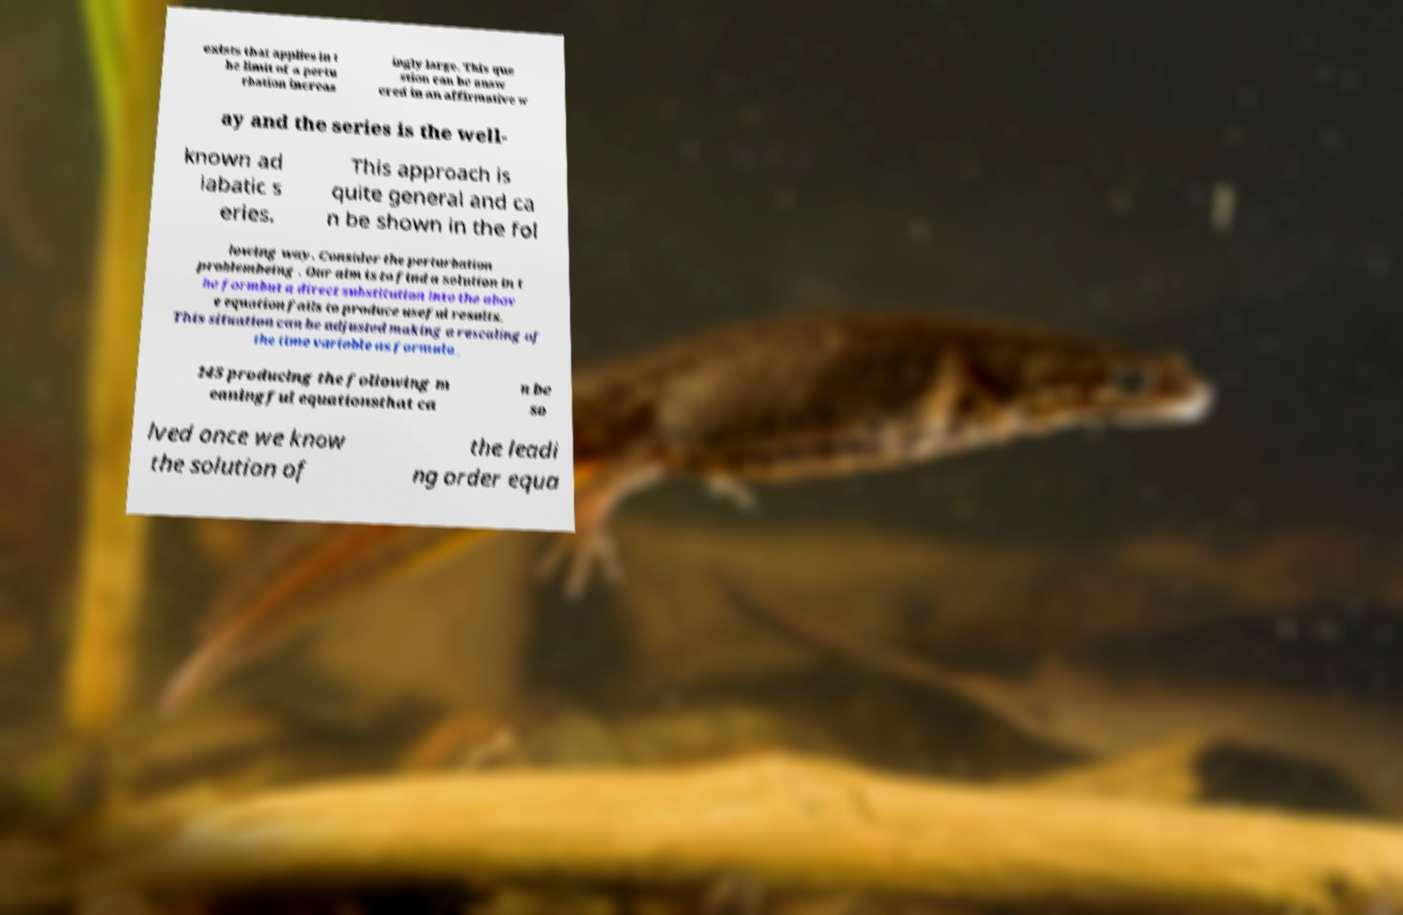For documentation purposes, I need the text within this image transcribed. Could you provide that? exists that applies in t he limit of a pertu rbation increas ingly large. This que stion can be answ ered in an affirmative w ay and the series is the well- known ad iabatic s eries. This approach is quite general and ca n be shown in the fol lowing way. Consider the perturbation problembeing . Our aim is to find a solution in t he formbut a direct substitution into the abov e equation fails to produce useful results. This situation can be adjusted making a rescaling of the time variable as formula_ 145 producing the following m eaningful equationsthat ca n be so lved once we know the solution of the leadi ng order equa 